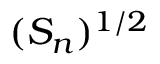Convert formula to latex. <formula><loc_0><loc_0><loc_500><loc_500>( S _ { n } ) ^ { 1 / 2 }</formula> 